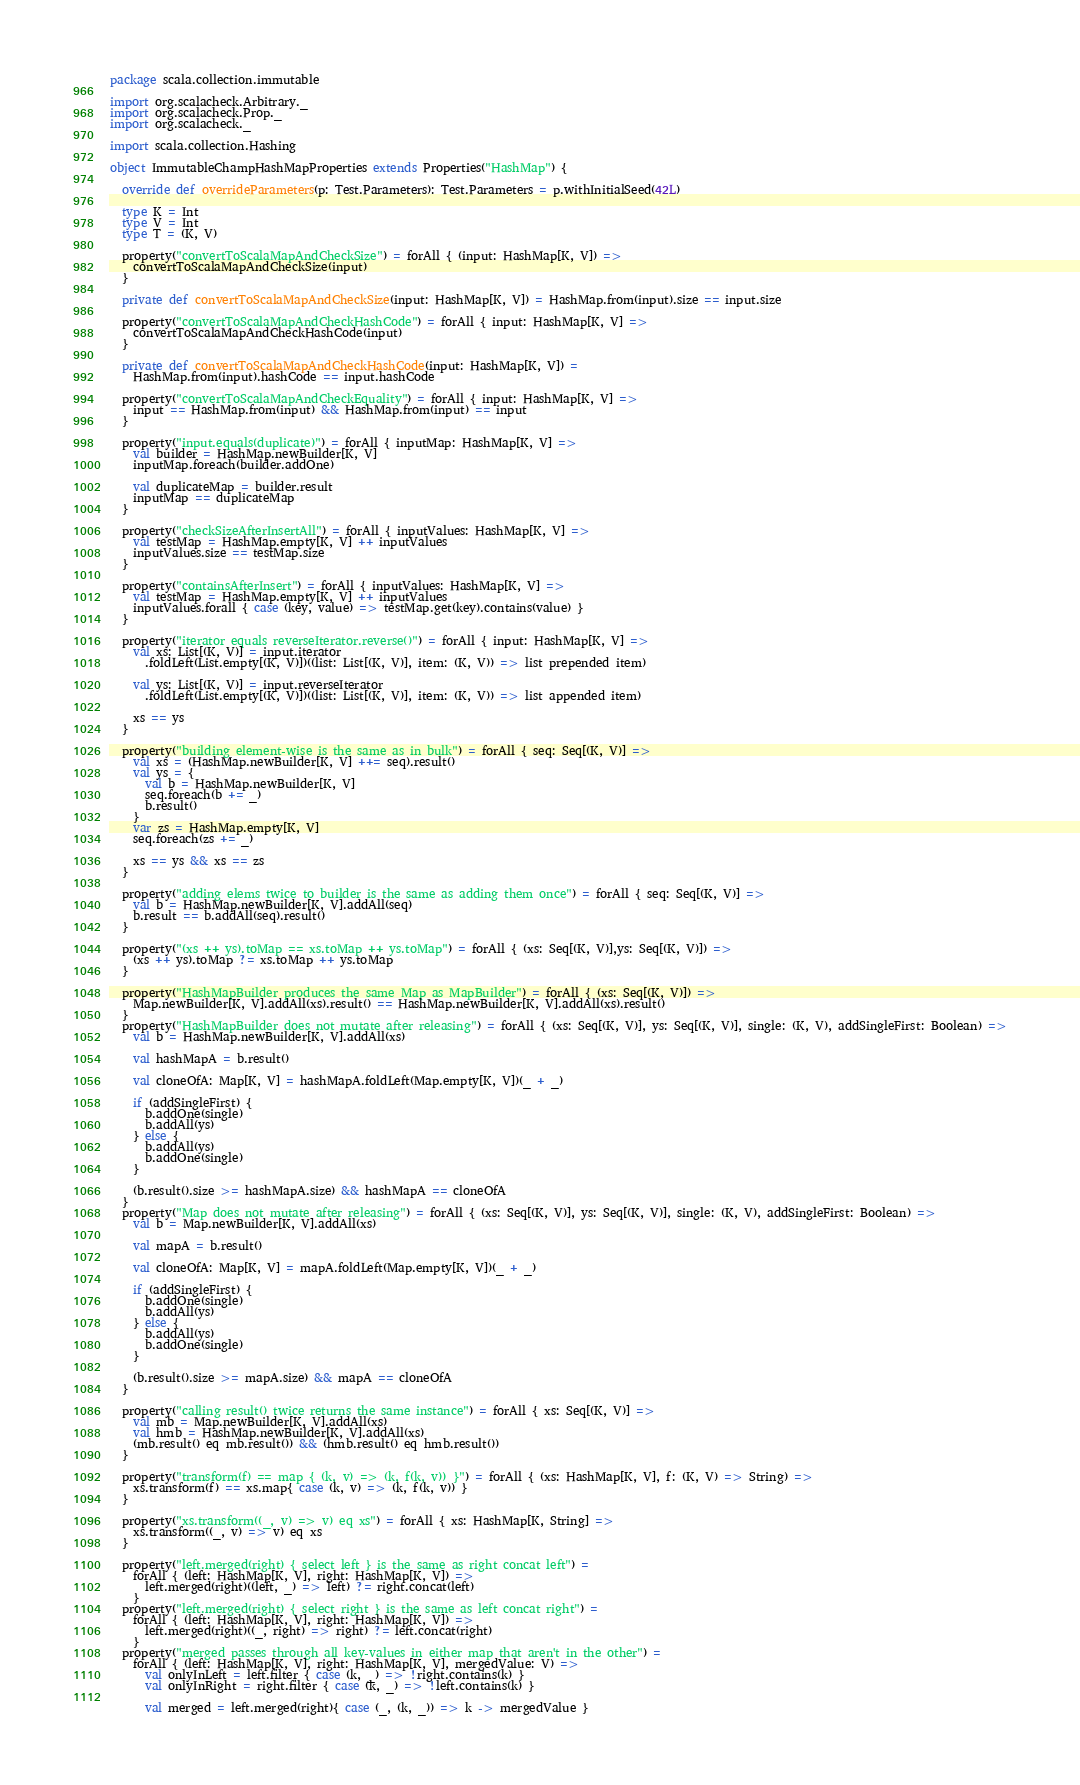Convert code to text. <code><loc_0><loc_0><loc_500><loc_500><_Scala_>package scala.collection.immutable

import org.scalacheck.Arbitrary._
import org.scalacheck.Prop._
import org.scalacheck._

import scala.collection.Hashing

object ImmutableChampHashMapProperties extends Properties("HashMap") {

  override def overrideParameters(p: Test.Parameters): Test.Parameters = p.withInitialSeed(42L)

  type K = Int
  type V = Int
  type T = (K, V)

  property("convertToScalaMapAndCheckSize") = forAll { (input: HashMap[K, V]) =>
    convertToScalaMapAndCheckSize(input)
  }

  private def convertToScalaMapAndCheckSize(input: HashMap[K, V]) = HashMap.from(input).size == input.size

  property("convertToScalaMapAndCheckHashCode") = forAll { input: HashMap[K, V] =>
    convertToScalaMapAndCheckHashCode(input)
  }

  private def convertToScalaMapAndCheckHashCode(input: HashMap[K, V]) =
    HashMap.from(input).hashCode == input.hashCode

  property("convertToScalaMapAndCheckEquality") = forAll { input: HashMap[K, V] =>
    input == HashMap.from(input) && HashMap.from(input) == input
  }

  property("input.equals(duplicate)") = forAll { inputMap: HashMap[K, V] =>
    val builder = HashMap.newBuilder[K, V]
    inputMap.foreach(builder.addOne)

    val duplicateMap = builder.result
    inputMap == duplicateMap
  }

  property("checkSizeAfterInsertAll") = forAll { inputValues: HashMap[K, V] =>
    val testMap = HashMap.empty[K, V] ++ inputValues
    inputValues.size == testMap.size
  }

  property("containsAfterInsert") = forAll { inputValues: HashMap[K, V] =>
    val testMap = HashMap.empty[K, V] ++ inputValues
    inputValues.forall { case (key, value) => testMap.get(key).contains(value) }
  }

  property("iterator equals reverseIterator.reverse()") = forAll { input: HashMap[K, V] =>
    val xs: List[(K, V)] = input.iterator
      .foldLeft(List.empty[(K, V)])((list: List[(K, V)], item: (K, V)) => list prepended item)

    val ys: List[(K, V)] = input.reverseIterator
      .foldLeft(List.empty[(K, V)])((list: List[(K, V)], item: (K, V)) => list appended item)

    xs == ys
  }

  property("building element-wise is the same as in bulk") = forAll { seq: Seq[(K, V)] =>
    val xs = (HashMap.newBuilder[K, V] ++= seq).result()
    val ys = {
      val b = HashMap.newBuilder[K, V]
      seq.foreach(b += _)
      b.result()
    }
    var zs = HashMap.empty[K, V]
    seq.foreach(zs += _)

    xs == ys && xs == zs
  }

  property("adding elems twice to builder is the same as adding them once") = forAll { seq: Seq[(K, V)] =>
    val b = HashMap.newBuilder[K, V].addAll(seq)
    b.result == b.addAll(seq).result()
  }

  property("(xs ++ ys).toMap == xs.toMap ++ ys.toMap") = forAll { (xs: Seq[(K, V)],ys: Seq[(K, V)]) =>
    (xs ++ ys).toMap ?= xs.toMap ++ ys.toMap
  }

  property("HashMapBuilder produces the same Map as MapBuilder") = forAll { (xs: Seq[(K, V)]) =>
    Map.newBuilder[K, V].addAll(xs).result() == HashMap.newBuilder[K, V].addAll(xs).result()
  }
  property("HashMapBuilder does not mutate after releasing") = forAll { (xs: Seq[(K, V)], ys: Seq[(K, V)], single: (K, V), addSingleFirst: Boolean) =>
    val b = HashMap.newBuilder[K, V].addAll(xs)

    val hashMapA = b.result()

    val cloneOfA: Map[K, V] = hashMapA.foldLeft(Map.empty[K, V])(_ + _)

    if (addSingleFirst) {
      b.addOne(single)
      b.addAll(ys)
    } else {
      b.addAll(ys)
      b.addOne(single)
    }

    (b.result().size >= hashMapA.size) && hashMapA == cloneOfA
  }
  property("Map does not mutate after releasing") = forAll { (xs: Seq[(K, V)], ys: Seq[(K, V)], single: (K, V), addSingleFirst: Boolean) =>
    val b = Map.newBuilder[K, V].addAll(xs)

    val mapA = b.result()

    val cloneOfA: Map[K, V] = mapA.foldLeft(Map.empty[K, V])(_ + _)

    if (addSingleFirst) {
      b.addOne(single)
      b.addAll(ys)
    } else {
      b.addAll(ys)
      b.addOne(single)
    }

    (b.result().size >= mapA.size) && mapA == cloneOfA
  }

  property("calling result() twice returns the same instance") = forAll { xs: Seq[(K, V)] =>
    val mb = Map.newBuilder[K, V].addAll(xs)
    val hmb = HashMap.newBuilder[K, V].addAll(xs)
    (mb.result() eq mb.result()) && (hmb.result() eq hmb.result())
  }

  property("transform(f) == map { (k, v) => (k, f(k, v)) }") = forAll { (xs: HashMap[K, V], f: (K, V) => String) =>
    xs.transform(f) == xs.map{ case (k, v) => (k, f(k, v)) }
  }

  property("xs.transform((_, v) => v) eq xs") = forAll { xs: HashMap[K, String] =>
    xs.transform((_, v) => v) eq xs
  }

  property("left.merged(right) { select left } is the same as right concat left") =
    forAll { (left: HashMap[K, V], right: HashMap[K, V]) =>
      left.merged(right)((left, _) => left) ?= right.concat(left)
    }
  property("left.merged(right) { select right } is the same as left concat right") =
    forAll { (left: HashMap[K, V], right: HashMap[K, V]) =>
      left.merged(right)((_, right) => right) ?= left.concat(right)
    }
  property("merged passes through all key-values in either map that aren't in the other") =
    forAll { (left: HashMap[K, V], right: HashMap[K, V], mergedValue: V) =>
      val onlyInLeft = left.filter { case (k, _) => !right.contains(k) }
      val onlyInRight = right.filter { case (k, _) => !left.contains(k) }

      val merged = left.merged(right){ case (_, (k, _)) => k -> mergedValue }
</code> 